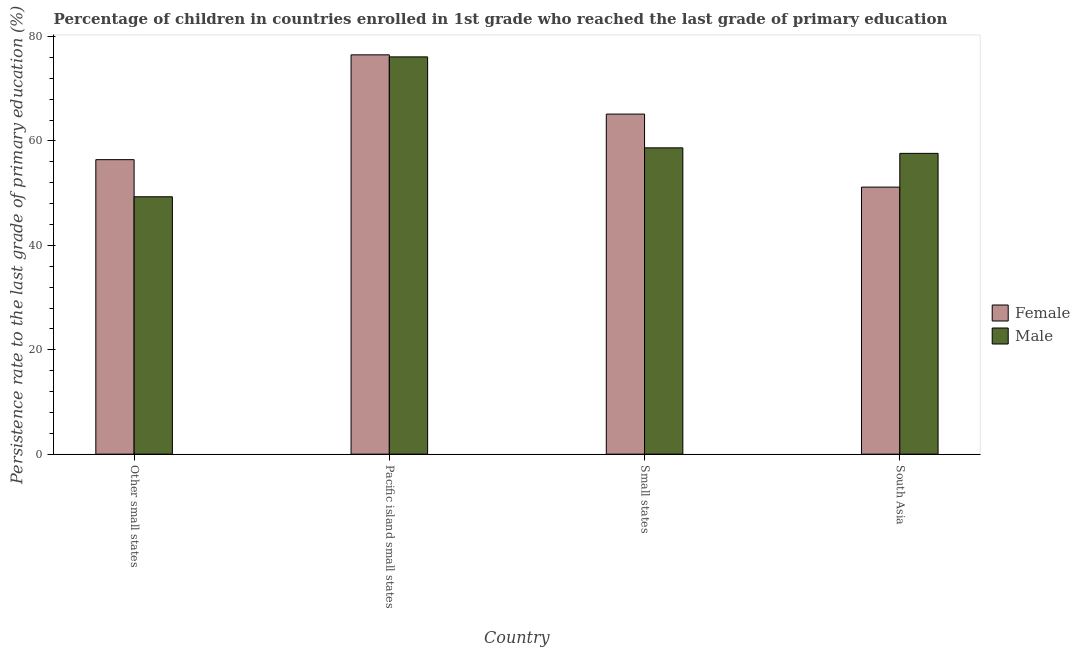How many different coloured bars are there?
Ensure brevity in your answer.  2. How many groups of bars are there?
Keep it short and to the point. 4. Are the number of bars per tick equal to the number of legend labels?
Provide a succinct answer. Yes. What is the label of the 1st group of bars from the left?
Keep it short and to the point. Other small states. What is the persistence rate of female students in Other small states?
Give a very brief answer. 56.42. Across all countries, what is the maximum persistence rate of male students?
Your answer should be compact. 76.11. Across all countries, what is the minimum persistence rate of female students?
Make the answer very short. 51.16. In which country was the persistence rate of female students maximum?
Keep it short and to the point. Pacific island small states. In which country was the persistence rate of male students minimum?
Ensure brevity in your answer.  Other small states. What is the total persistence rate of male students in the graph?
Make the answer very short. 241.72. What is the difference between the persistence rate of female students in Small states and that in South Asia?
Your answer should be compact. 13.99. What is the difference between the persistence rate of female students in Pacific island small states and the persistence rate of male students in South Asia?
Give a very brief answer. 18.87. What is the average persistence rate of male students per country?
Give a very brief answer. 60.43. What is the difference between the persistence rate of female students and persistence rate of male students in South Asia?
Offer a very short reply. -6.47. What is the ratio of the persistence rate of male students in Other small states to that in South Asia?
Provide a succinct answer. 0.86. Is the difference between the persistence rate of female students in Small states and South Asia greater than the difference between the persistence rate of male students in Small states and South Asia?
Your answer should be compact. Yes. What is the difference between the highest and the second highest persistence rate of female students?
Ensure brevity in your answer.  11.35. What is the difference between the highest and the lowest persistence rate of male students?
Provide a short and direct response. 26.8. In how many countries, is the persistence rate of male students greater than the average persistence rate of male students taken over all countries?
Keep it short and to the point. 1. Is the sum of the persistence rate of female students in Other small states and Pacific island small states greater than the maximum persistence rate of male students across all countries?
Keep it short and to the point. Yes. What does the 2nd bar from the left in Pacific island small states represents?
Offer a very short reply. Male. What does the 2nd bar from the right in Small states represents?
Your answer should be very brief. Female. Are all the bars in the graph horizontal?
Your response must be concise. No. How are the legend labels stacked?
Offer a terse response. Vertical. What is the title of the graph?
Your answer should be compact. Percentage of children in countries enrolled in 1st grade who reached the last grade of primary education. Does "Arms imports" appear as one of the legend labels in the graph?
Make the answer very short. No. What is the label or title of the Y-axis?
Provide a succinct answer. Persistence rate to the last grade of primary education (%). What is the Persistence rate to the last grade of primary education (%) of Female in Other small states?
Provide a succinct answer. 56.42. What is the Persistence rate to the last grade of primary education (%) of Male in Other small states?
Your answer should be compact. 49.31. What is the Persistence rate to the last grade of primary education (%) in Female in Pacific island small states?
Offer a very short reply. 76.5. What is the Persistence rate to the last grade of primary education (%) in Male in Pacific island small states?
Make the answer very short. 76.11. What is the Persistence rate to the last grade of primary education (%) in Female in Small states?
Keep it short and to the point. 65.15. What is the Persistence rate to the last grade of primary education (%) of Male in Small states?
Offer a terse response. 58.68. What is the Persistence rate to the last grade of primary education (%) in Female in South Asia?
Offer a terse response. 51.16. What is the Persistence rate to the last grade of primary education (%) in Male in South Asia?
Your answer should be compact. 57.63. Across all countries, what is the maximum Persistence rate to the last grade of primary education (%) of Female?
Your answer should be compact. 76.5. Across all countries, what is the maximum Persistence rate to the last grade of primary education (%) in Male?
Provide a succinct answer. 76.11. Across all countries, what is the minimum Persistence rate to the last grade of primary education (%) of Female?
Your answer should be very brief. 51.16. Across all countries, what is the minimum Persistence rate to the last grade of primary education (%) of Male?
Keep it short and to the point. 49.31. What is the total Persistence rate to the last grade of primary education (%) in Female in the graph?
Offer a very short reply. 249.23. What is the total Persistence rate to the last grade of primary education (%) of Male in the graph?
Your answer should be compact. 241.72. What is the difference between the Persistence rate to the last grade of primary education (%) of Female in Other small states and that in Pacific island small states?
Your answer should be compact. -20.08. What is the difference between the Persistence rate to the last grade of primary education (%) of Male in Other small states and that in Pacific island small states?
Give a very brief answer. -26.8. What is the difference between the Persistence rate to the last grade of primary education (%) in Female in Other small states and that in Small states?
Provide a succinct answer. -8.73. What is the difference between the Persistence rate to the last grade of primary education (%) of Male in Other small states and that in Small states?
Make the answer very short. -9.37. What is the difference between the Persistence rate to the last grade of primary education (%) of Female in Other small states and that in South Asia?
Provide a short and direct response. 5.26. What is the difference between the Persistence rate to the last grade of primary education (%) of Male in Other small states and that in South Asia?
Provide a succinct answer. -8.32. What is the difference between the Persistence rate to the last grade of primary education (%) in Female in Pacific island small states and that in Small states?
Provide a succinct answer. 11.35. What is the difference between the Persistence rate to the last grade of primary education (%) of Male in Pacific island small states and that in Small states?
Keep it short and to the point. 17.43. What is the difference between the Persistence rate to the last grade of primary education (%) in Female in Pacific island small states and that in South Asia?
Keep it short and to the point. 25.34. What is the difference between the Persistence rate to the last grade of primary education (%) of Male in Pacific island small states and that in South Asia?
Make the answer very short. 18.48. What is the difference between the Persistence rate to the last grade of primary education (%) in Female in Small states and that in South Asia?
Offer a terse response. 13.99. What is the difference between the Persistence rate to the last grade of primary education (%) of Male in Small states and that in South Asia?
Your answer should be very brief. 1.06. What is the difference between the Persistence rate to the last grade of primary education (%) of Female in Other small states and the Persistence rate to the last grade of primary education (%) of Male in Pacific island small states?
Ensure brevity in your answer.  -19.69. What is the difference between the Persistence rate to the last grade of primary education (%) in Female in Other small states and the Persistence rate to the last grade of primary education (%) in Male in Small states?
Your answer should be very brief. -2.26. What is the difference between the Persistence rate to the last grade of primary education (%) of Female in Other small states and the Persistence rate to the last grade of primary education (%) of Male in South Asia?
Keep it short and to the point. -1.21. What is the difference between the Persistence rate to the last grade of primary education (%) in Female in Pacific island small states and the Persistence rate to the last grade of primary education (%) in Male in Small states?
Your response must be concise. 17.82. What is the difference between the Persistence rate to the last grade of primary education (%) in Female in Pacific island small states and the Persistence rate to the last grade of primary education (%) in Male in South Asia?
Make the answer very short. 18.87. What is the difference between the Persistence rate to the last grade of primary education (%) of Female in Small states and the Persistence rate to the last grade of primary education (%) of Male in South Asia?
Your answer should be very brief. 7.52. What is the average Persistence rate to the last grade of primary education (%) of Female per country?
Provide a succinct answer. 62.31. What is the average Persistence rate to the last grade of primary education (%) in Male per country?
Give a very brief answer. 60.43. What is the difference between the Persistence rate to the last grade of primary education (%) in Female and Persistence rate to the last grade of primary education (%) in Male in Other small states?
Provide a short and direct response. 7.11. What is the difference between the Persistence rate to the last grade of primary education (%) of Female and Persistence rate to the last grade of primary education (%) of Male in Pacific island small states?
Offer a very short reply. 0.39. What is the difference between the Persistence rate to the last grade of primary education (%) in Female and Persistence rate to the last grade of primary education (%) in Male in Small states?
Provide a short and direct response. 6.47. What is the difference between the Persistence rate to the last grade of primary education (%) of Female and Persistence rate to the last grade of primary education (%) of Male in South Asia?
Offer a terse response. -6.47. What is the ratio of the Persistence rate to the last grade of primary education (%) of Female in Other small states to that in Pacific island small states?
Your response must be concise. 0.74. What is the ratio of the Persistence rate to the last grade of primary education (%) of Male in Other small states to that in Pacific island small states?
Keep it short and to the point. 0.65. What is the ratio of the Persistence rate to the last grade of primary education (%) of Female in Other small states to that in Small states?
Your answer should be compact. 0.87. What is the ratio of the Persistence rate to the last grade of primary education (%) of Male in Other small states to that in Small states?
Provide a short and direct response. 0.84. What is the ratio of the Persistence rate to the last grade of primary education (%) in Female in Other small states to that in South Asia?
Make the answer very short. 1.1. What is the ratio of the Persistence rate to the last grade of primary education (%) of Male in Other small states to that in South Asia?
Your answer should be very brief. 0.86. What is the ratio of the Persistence rate to the last grade of primary education (%) in Female in Pacific island small states to that in Small states?
Offer a terse response. 1.17. What is the ratio of the Persistence rate to the last grade of primary education (%) of Male in Pacific island small states to that in Small states?
Offer a very short reply. 1.3. What is the ratio of the Persistence rate to the last grade of primary education (%) in Female in Pacific island small states to that in South Asia?
Your response must be concise. 1.5. What is the ratio of the Persistence rate to the last grade of primary education (%) in Male in Pacific island small states to that in South Asia?
Ensure brevity in your answer.  1.32. What is the ratio of the Persistence rate to the last grade of primary education (%) of Female in Small states to that in South Asia?
Ensure brevity in your answer.  1.27. What is the ratio of the Persistence rate to the last grade of primary education (%) of Male in Small states to that in South Asia?
Ensure brevity in your answer.  1.02. What is the difference between the highest and the second highest Persistence rate to the last grade of primary education (%) of Female?
Give a very brief answer. 11.35. What is the difference between the highest and the second highest Persistence rate to the last grade of primary education (%) in Male?
Provide a succinct answer. 17.43. What is the difference between the highest and the lowest Persistence rate to the last grade of primary education (%) in Female?
Give a very brief answer. 25.34. What is the difference between the highest and the lowest Persistence rate to the last grade of primary education (%) in Male?
Make the answer very short. 26.8. 